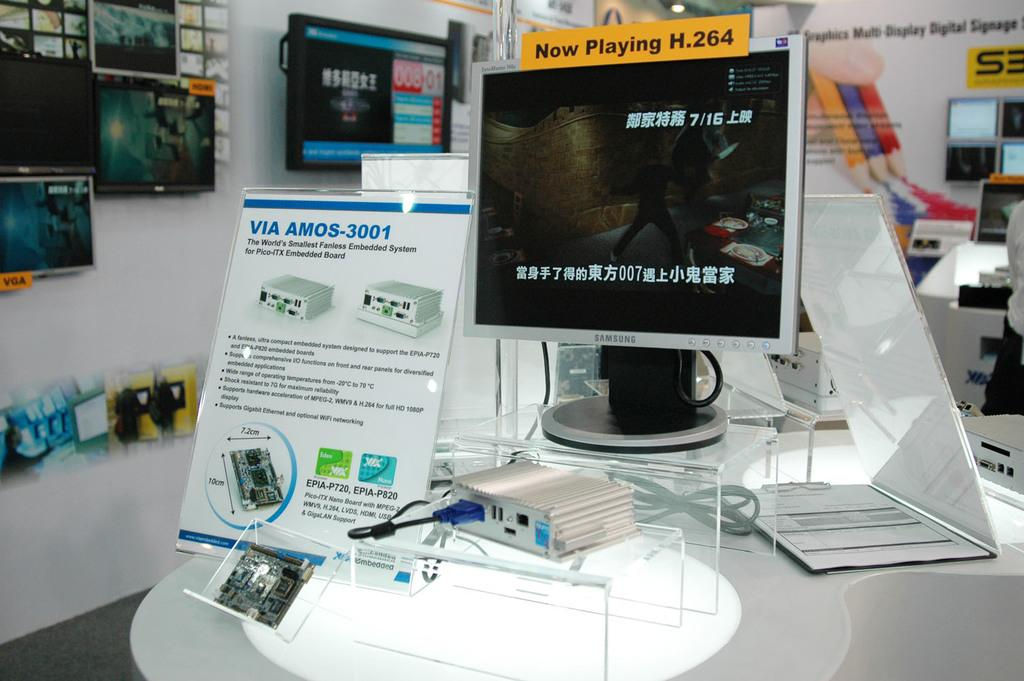<image>
Give a short and clear explanation of the subsequent image. A brochure about Amos-3001 which is the smallest fanless embedded system 